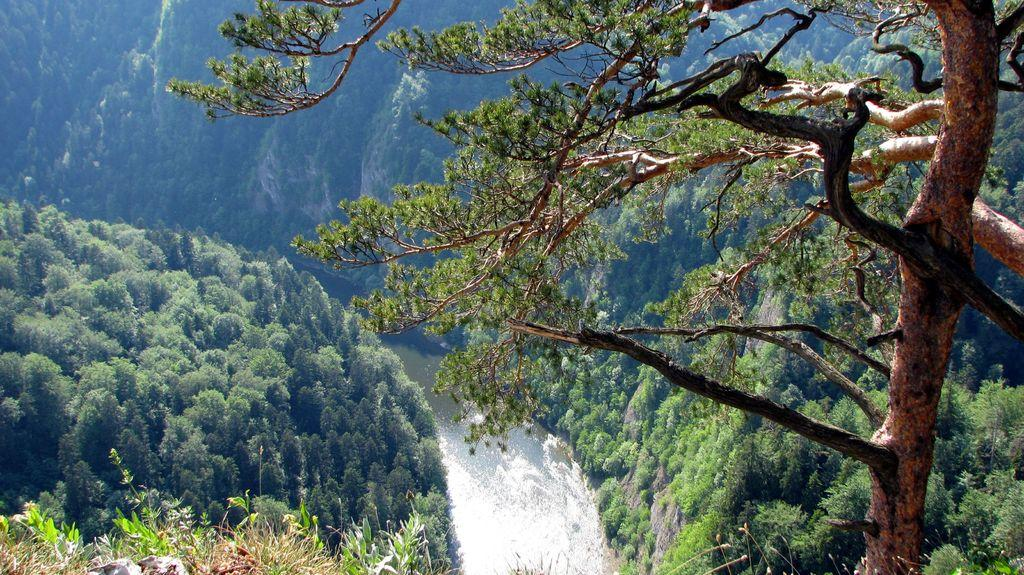What type of vegetation can be seen in the image? There are trees in the image. What else can be seen at the bottom of the image? There is water visible at the bottom of the image. Where are the plants located in the image? The plants are on the bottom left side of the image. Can you tell me how many bees are fighting in the image? There are no bees or fights present in the image; it features trees, water, and plants. 